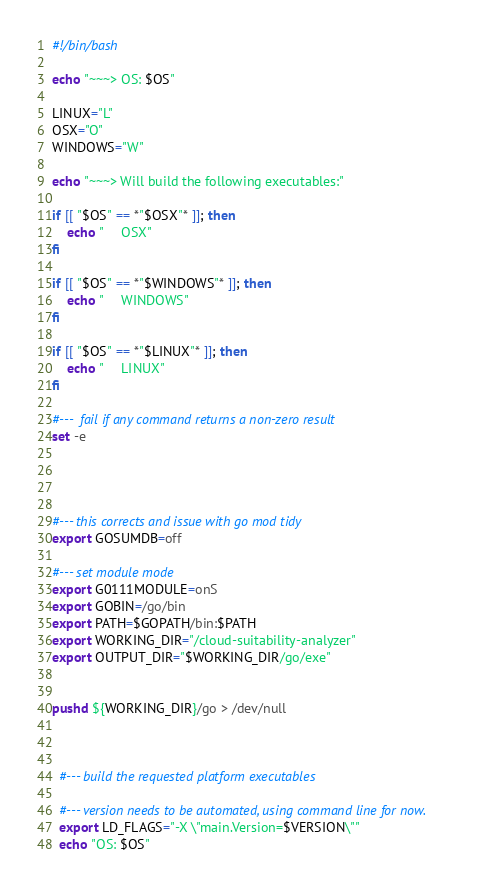<code> <loc_0><loc_0><loc_500><loc_500><_Bash_>#!/bin/bash

echo "~~~> OS: $OS"

LINUX="L"
OSX="O"
WINDOWS="W"

echo "~~~> Will build the following executables:"

if [[ "$OS" == *"$OSX"* ]]; then
    echo "     OSX"
fi

if [[ "$OS" == *"$WINDOWS"* ]]; then
    echo "     WINDOWS"
fi

if [[ "$OS" == *"$LINUX"* ]]; then
    echo "     LINUX"
fi

#---  fail if any command returns a non-zero result
set -e




#--- this corrects and issue with go mod tidy
export GOSUMDB=off

#--- set module mode
export G0111MODULE=onS
export GOBIN=/go/bin
export PATH=$GOPATH/bin:$PATH
export WORKING_DIR="/cloud-suitability-analyzer"
export OUTPUT_DIR="$WORKING_DIR/go/exe"


pushd ${WORKING_DIR}/go > /dev/null



  #--- build the requested platform executables

  #--- version needs to be automated, using command line for now.
  export LD_FLAGS="-X \"main.Version=$VERSION\"" 
  echo "OS: $OS"</code> 